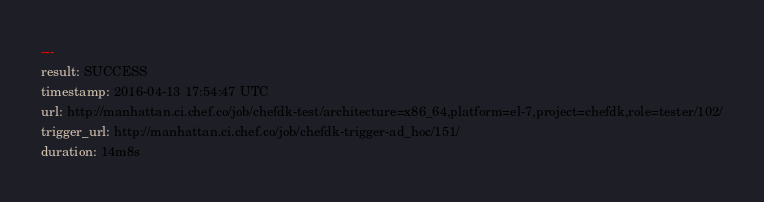<code> <loc_0><loc_0><loc_500><loc_500><_YAML_>---
result: SUCCESS
timestamp: 2016-04-13 17:54:47 UTC
url: http://manhattan.ci.chef.co/job/chefdk-test/architecture=x86_64,platform=el-7,project=chefdk,role=tester/102/
trigger_url: http://manhattan.ci.chef.co/job/chefdk-trigger-ad_hoc/151/
duration: 14m8s
</code> 